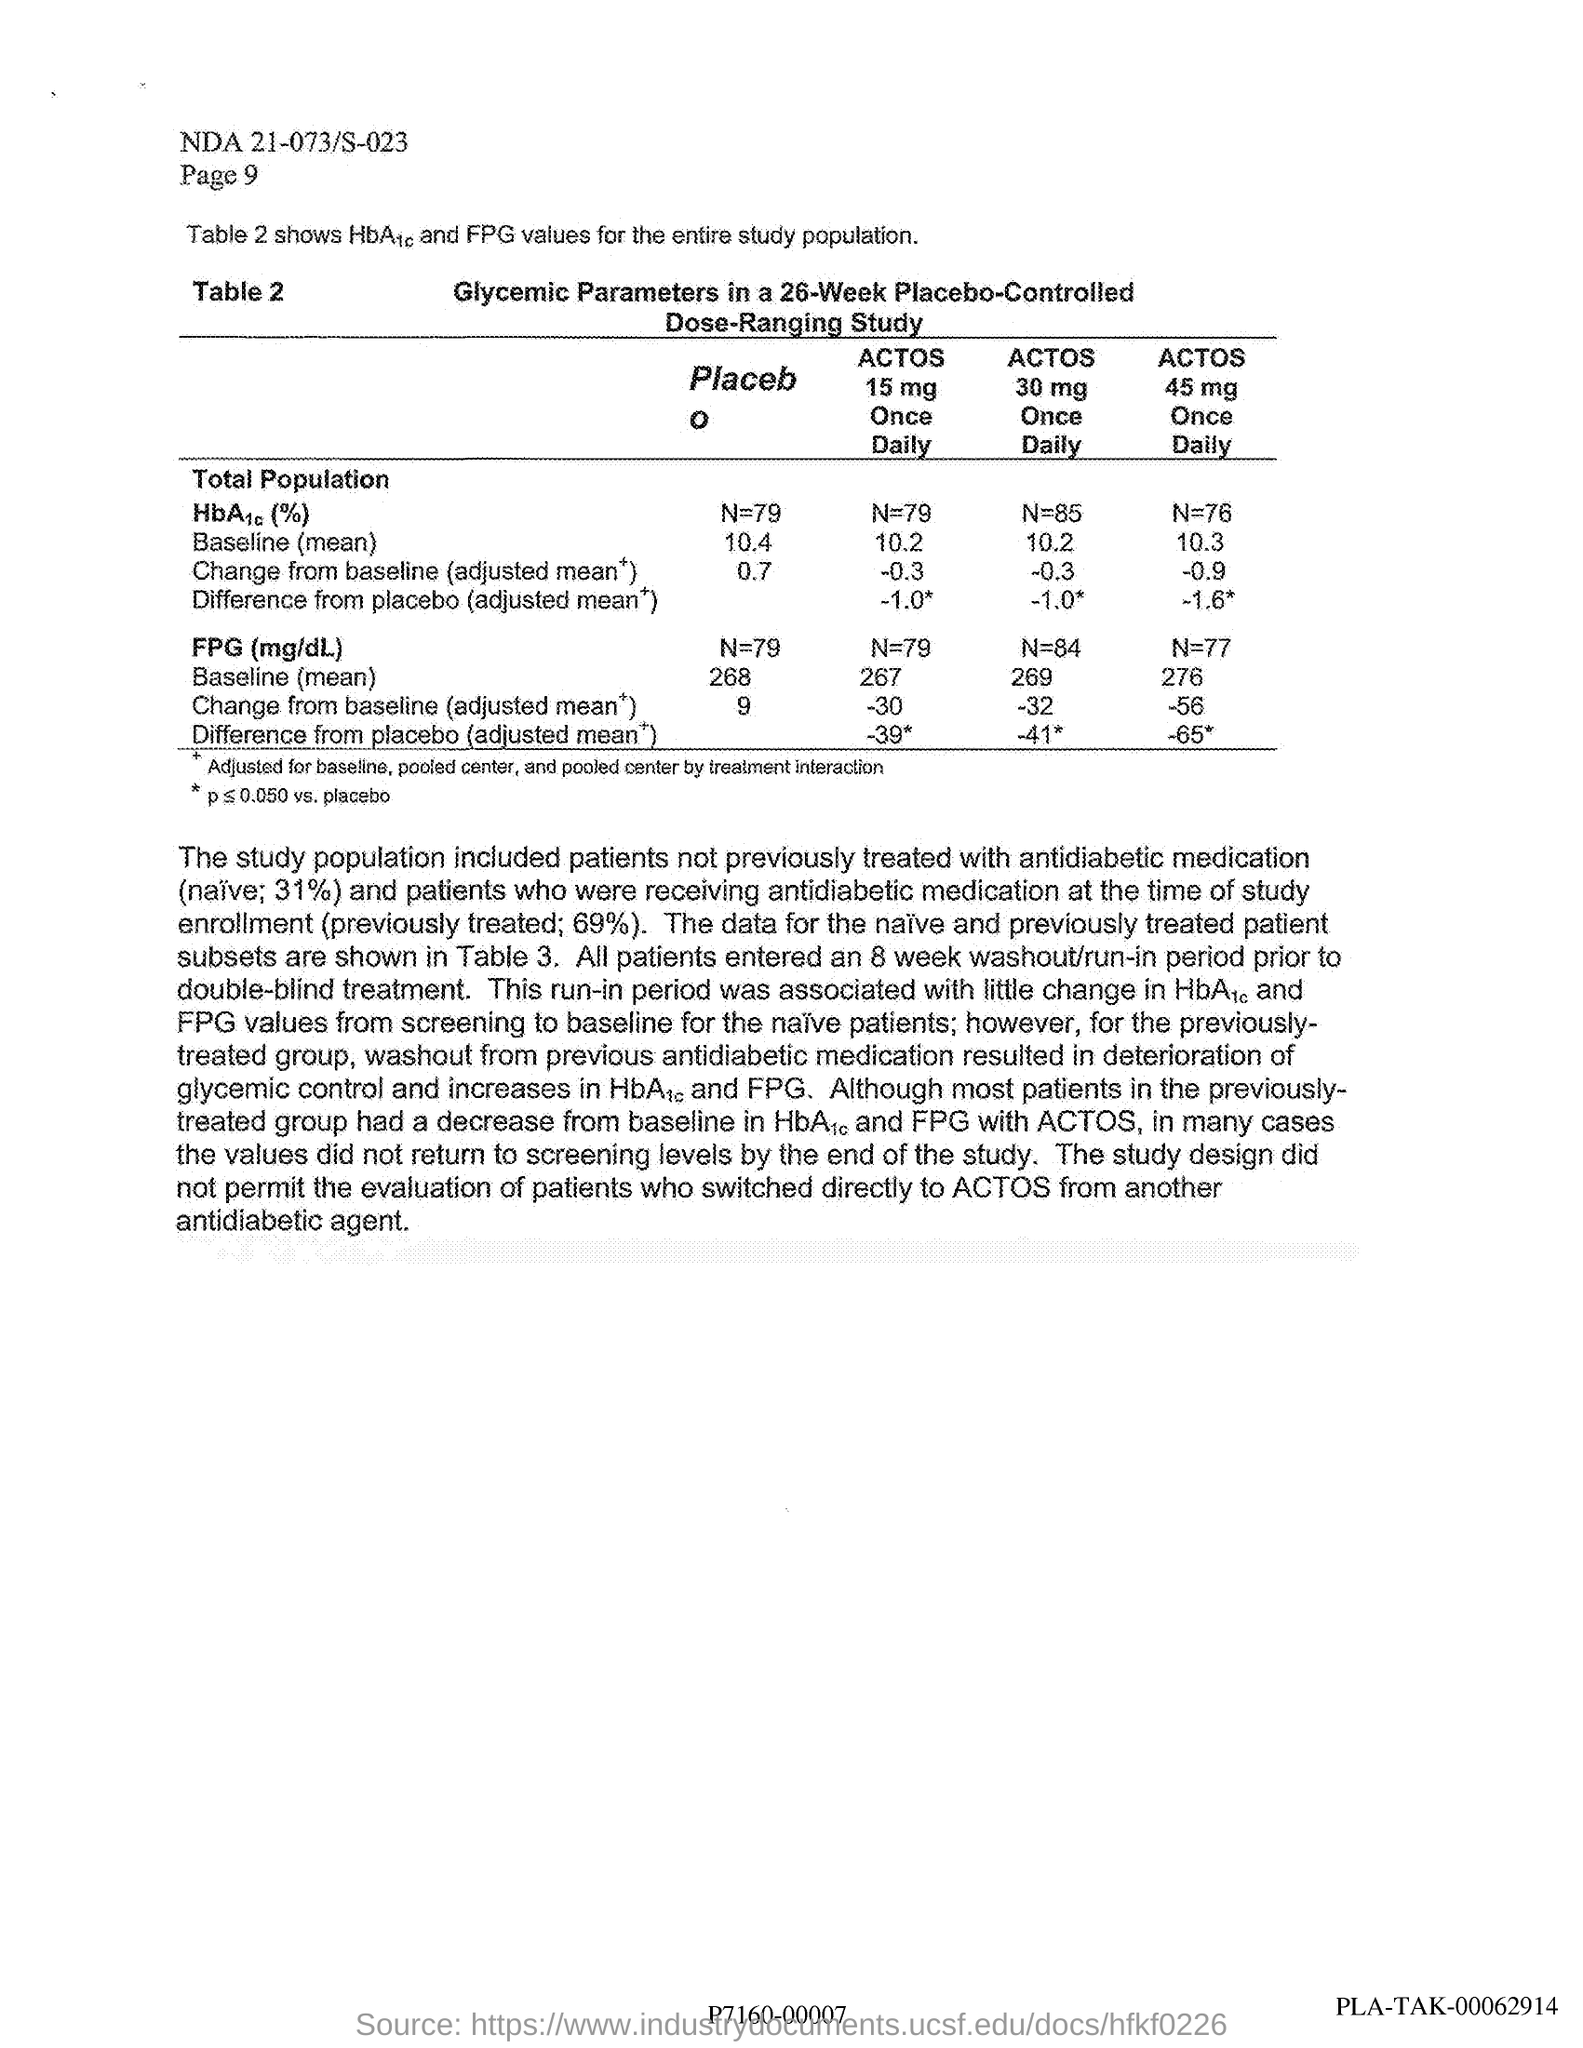What study is described in the table given?
Offer a terse response. PLACEBO- CONTROLLED DOSE RANGING STUDY. Which parameters are considered for the study(see heading of table 2)?
Your answer should be very brief. Glycemic Parameters. Prior to what, the patients entered an 8 week washout/run-in-period?
Your response must be concise. Double-blind treatment. 